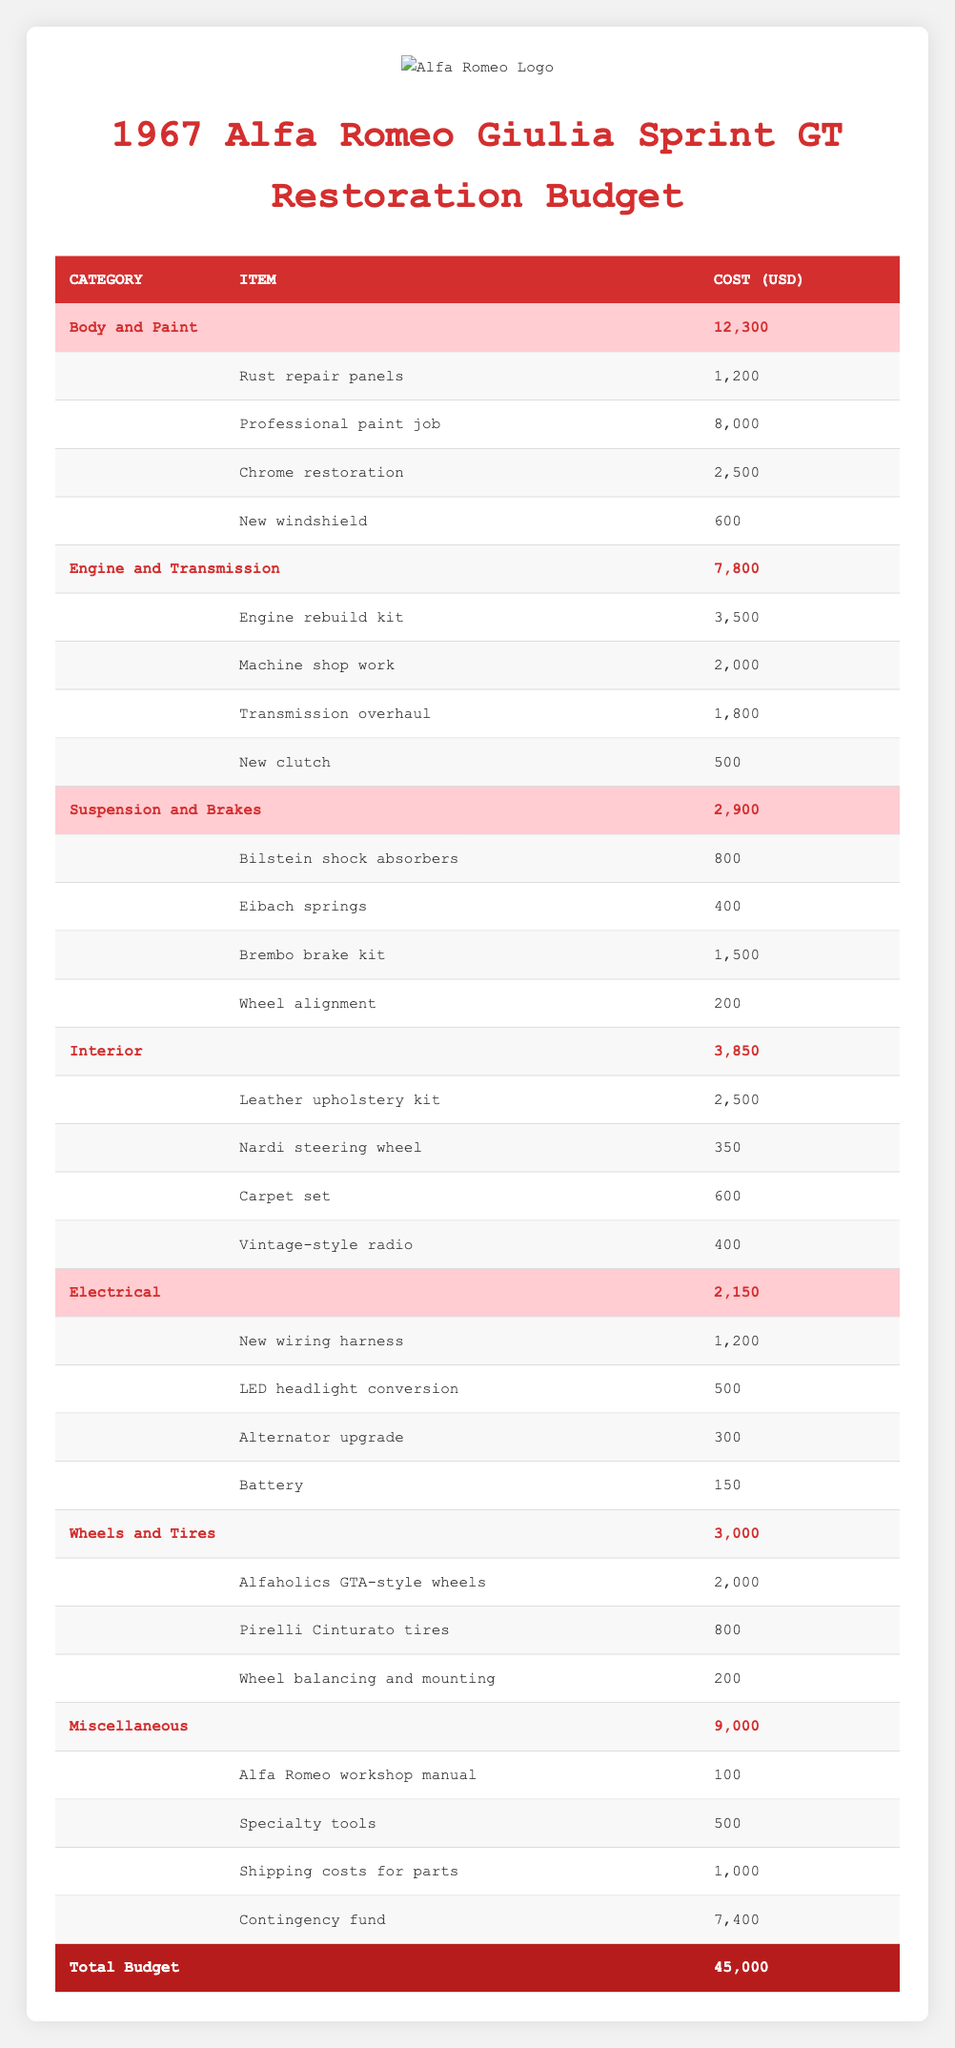What is the total budget for the restoration project? The total budget for the restoration project is provided at the bottom of the table. It clearly states "Total Budget" with a cost of 45,000.
Answer: 45,000 How much does the professional paint job cost? The cost of the professional paint job is listed under the "Body and Paint" category in the table, which specifies the cost as 8,000.
Answer: 8,000 What is the combined cost of the items in the "Electrical" category? The total cost for the "Electrical" category is displayed in the table as 2,150, which is derived from summing all individual item costs: 1,200 + 500 + 300 + 150 = 2,150.
Answer: 2,150 Is the cost of the leather upholstery kit greater than the cost of shipping costs for parts? The leather upholstery kit costs 2,500 while shipping costs for parts are 1,000. Since 2,500 is greater than 1,000, the statement is true.
Answer: Yes How much do the wheels and tires cost in total compared to the original budget? The cost for "Wheels and Tires" is 3,000. To compare, we evaluate if this is less than the total budget of 45,000. Since 3,000 is indeed less than 45,000, it confirms the relation.
Answer: 3,000 is less than 45,000 What is the percentage of the total budget allocated for "Miscellaneous" expenses? The "Miscellaneous" category costs 9,000. To find the percentage of the total budget allocated for miscellaneous expenses, we calculate (9,000 / 45,000) * 100 = 20%. This shows that 20% of the budget is allocated to miscellaneous expenses.
Answer: 20% Which category has the highest total cost, and what is that cost? By comparing the totals of each category provided in the table, "Body and Paint" has a total cost of 12,300, which is the highest. This is confirmed by checking the cost of all listed categories.
Answer: Body and Paint, 12,300 How much would the total cost increase if the contingency fund was doubled? The current contingency fund is 7,400. If it is doubled, the new cost would be 7,400 * 2 = 14,800. Therefore, the total increase in cost would be 14,800 - 7,400 = 7,400, meaning the overall budget would rise to 45,000 + 7,400 = 52,400.
Answer: 7,400 increase What is the total cost for all items in the "Suspension and Brakes" category? The total for "Suspension and Brakes" is summed by adding all items: 800 + 400 + 1,500 + 200 = 2,900. This is reflected in the table right under this category.
Answer: 2,900 